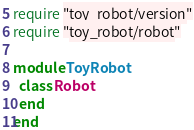Convert code to text. <code><loc_0><loc_0><loc_500><loc_500><_Ruby_>require "toy_robot/version"
require "toy_robot/robot"

module ToyRobot
  class Robot
  end
end
</code> 